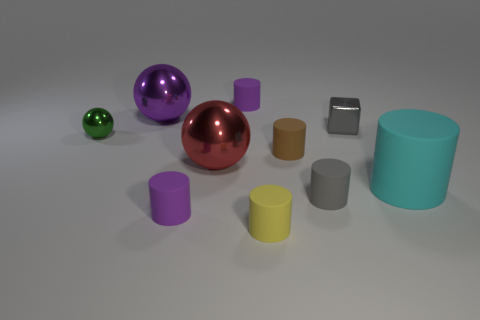Is there anything else that is the same shape as the small gray shiny thing?
Ensure brevity in your answer.  No. There is a metallic block; does it have the same color as the tiny matte thing on the right side of the tiny brown cylinder?
Offer a terse response. Yes. Are there any cyan things that have the same size as the gray metallic thing?
Provide a short and direct response. No. What is the tiny purple cylinder that is in front of the gray thing behind the gray matte thing made of?
Offer a terse response. Rubber. What number of tiny rubber cylinders are the same color as the metallic block?
Ensure brevity in your answer.  1. The big red object that is the same material as the cube is what shape?
Offer a very short reply. Sphere. There is a shiny sphere that is behind the small green shiny thing; what is its size?
Provide a succinct answer. Large. Are there the same number of small green shiny objects that are in front of the big rubber cylinder and small purple rubber cylinders that are right of the gray cylinder?
Your answer should be very brief. Yes. There is a large metal thing that is behind the small metallic object that is left of the big thing that is behind the green sphere; what color is it?
Offer a terse response. Purple. What number of tiny cylinders are to the left of the small gray cylinder and behind the small yellow cylinder?
Your response must be concise. 3. 